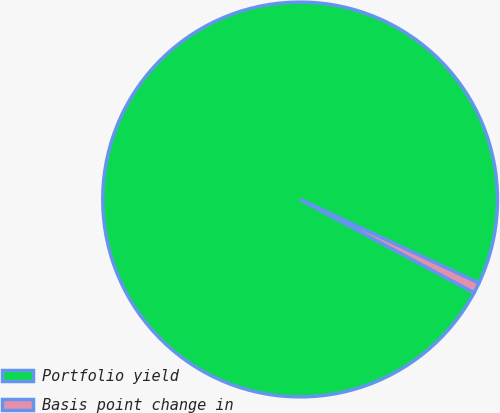Convert chart. <chart><loc_0><loc_0><loc_500><loc_500><pie_chart><fcel>Portfolio yield<fcel>Basis point change in<nl><fcel>99.13%<fcel>0.87%<nl></chart> 